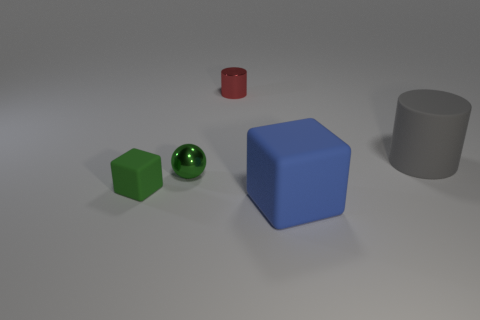Add 4 large matte things. How many objects exist? 9 Subtract all gray cylinders. How many cylinders are left? 1 Subtract all cubes. How many objects are left? 3 Subtract all cyan blocks. Subtract all cyan cylinders. How many blocks are left? 2 Subtract all shiny spheres. Subtract all green metallic spheres. How many objects are left? 3 Add 5 tiny green balls. How many tiny green balls are left? 6 Add 1 cubes. How many cubes exist? 3 Subtract 0 red cubes. How many objects are left? 5 